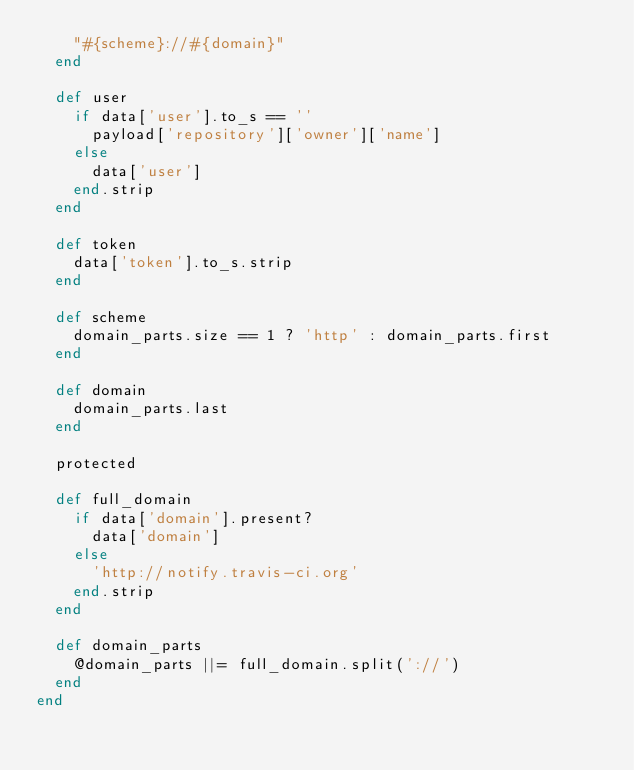Convert code to text. <code><loc_0><loc_0><loc_500><loc_500><_Ruby_>    "#{scheme}://#{domain}"
  end

  def user
    if data['user'].to_s == ''
      payload['repository']['owner']['name']
    else
      data['user']
    end.strip
  end

  def token
    data['token'].to_s.strip
  end

  def scheme
    domain_parts.size == 1 ? 'http' : domain_parts.first
  end

  def domain
    domain_parts.last
  end

  protected

  def full_domain
    if data['domain'].present?
      data['domain']
    else
      'http://notify.travis-ci.org'
    end.strip
  end

  def domain_parts
    @domain_parts ||= full_domain.split('://')
  end
end

</code> 